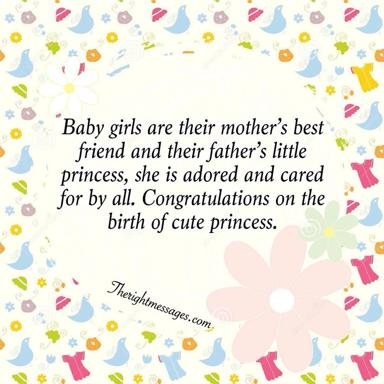What is the main message in the text on the image? The primary sentiment expressed in the image’s text is a heartfelt celebration for the birth of a baby girl, poetically describing her as the mother's best friend and the father's little princess. It emphasizes the joy and special bond parents form with their daughters, using affectionate and royal metaphors to highlight their cherished status in the family. 